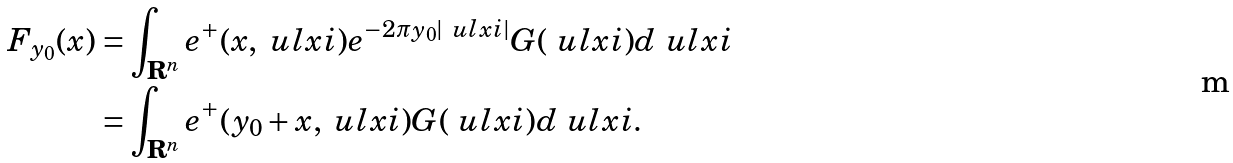Convert formula to latex. <formula><loc_0><loc_0><loc_500><loc_500>F _ { y _ { 0 } } ( x ) & = \int _ { \mathbf R ^ { n } } e ^ { + } ( x , \ u l x i ) e ^ { - 2 \pi y _ { 0 } | \ u l x i | } G ( \ u l x i ) d \ u l x i \\ & = \int _ { \mathbf R ^ { n } } e ^ { + } ( y _ { 0 } + x , \ u l x i ) G ( \ u l x i ) d \ u l x i .</formula> 